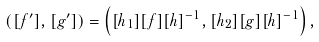<formula> <loc_0><loc_0><loc_500><loc_500>\left ( [ f ^ { \prime } ] , [ g ^ { \prime } ] \right ) = \left ( [ h _ { 1 } ] [ f ] [ h ] ^ { - 1 } , [ h _ { 2 } ] [ g ] [ h ] ^ { - 1 } \right ) ,</formula> 